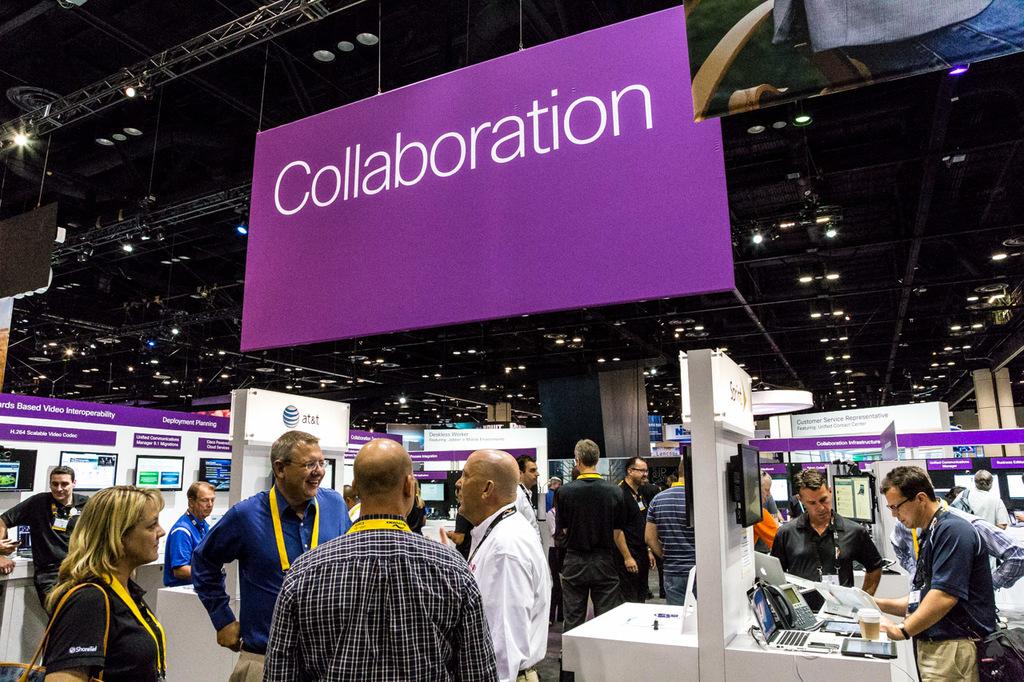What concept is the large hanging banner stating?
Give a very brief answer. Collaboration. 